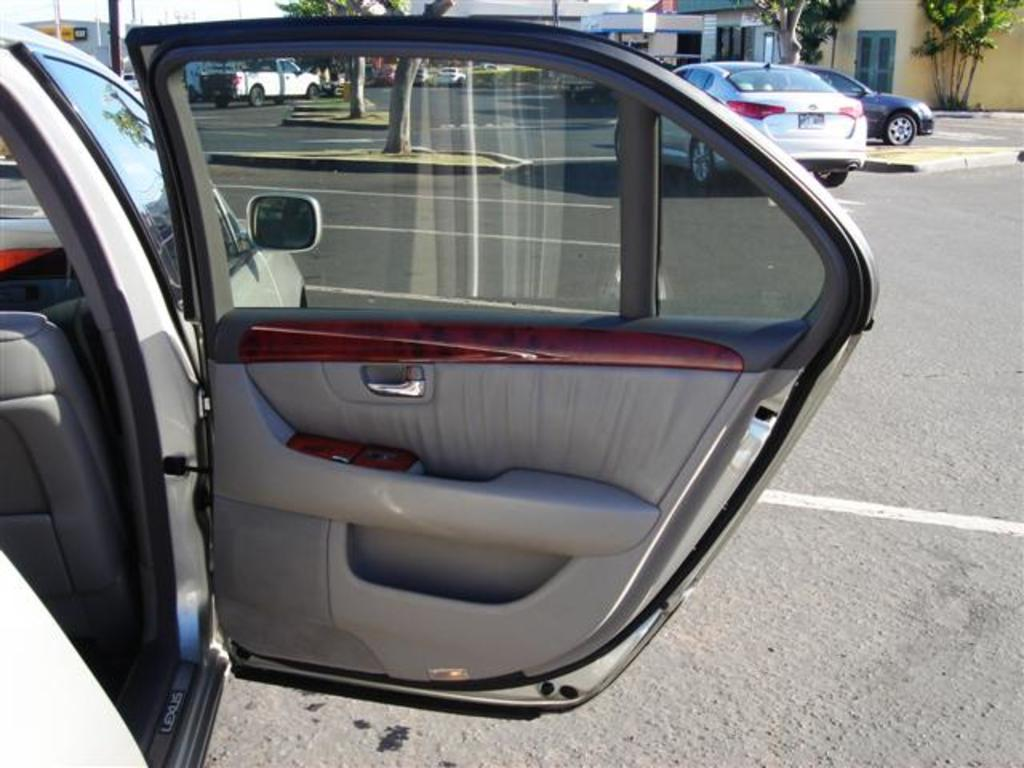What is the state of the car door in the image? The door of a car is opened in the image. What can be seen in the background of the image? There are vehicles on the road, a group of trees, poles, and buildings visible in the background. What type of wing can be seen on the car in the image? There is no wing visible on the car in the image. What kind of flag is being waved by the driver in the image? There is no driver or flag present in the image. 